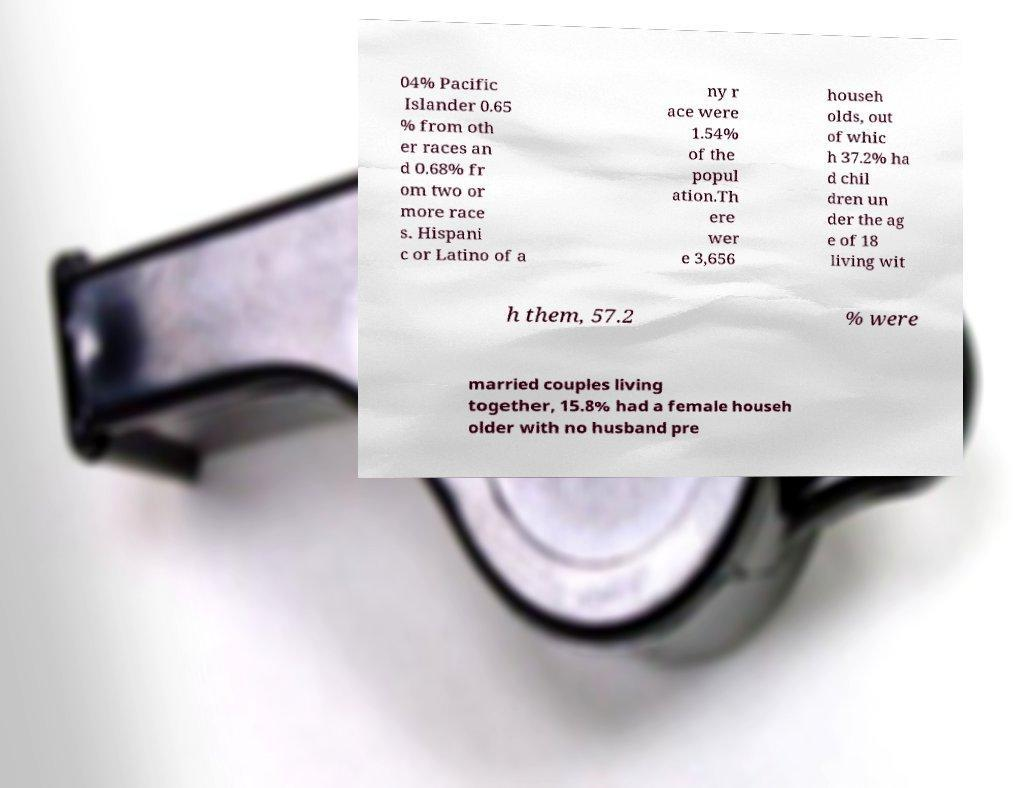For documentation purposes, I need the text within this image transcribed. Could you provide that? 04% Pacific Islander 0.65 % from oth er races an d 0.68% fr om two or more race s. Hispani c or Latino of a ny r ace were 1.54% of the popul ation.Th ere wer e 3,656 househ olds, out of whic h 37.2% ha d chil dren un der the ag e of 18 living wit h them, 57.2 % were married couples living together, 15.8% had a female househ older with no husband pre 